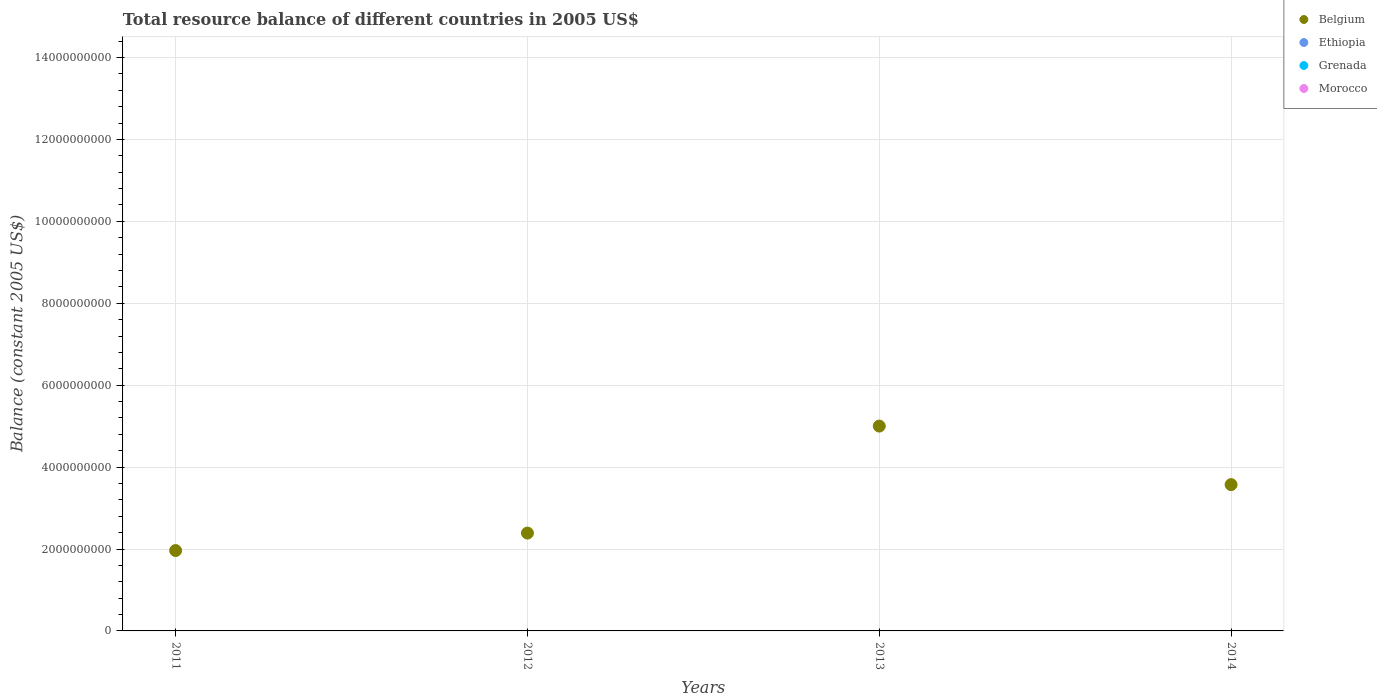Is the number of dotlines equal to the number of legend labels?
Provide a succinct answer. No. What is the total resource balance in Belgium in 2014?
Provide a succinct answer. 3.57e+09. Across all years, what is the maximum total resource balance in Belgium?
Provide a short and direct response. 5.00e+09. What is the total total resource balance in Belgium in the graph?
Offer a very short reply. 1.29e+1. What is the difference between the total resource balance in Belgium in 2011 and that in 2013?
Offer a terse response. -3.04e+09. What is the difference between the total resource balance in Ethiopia in 2011 and the total resource balance in Morocco in 2014?
Your answer should be compact. 0. What is the ratio of the total resource balance in Belgium in 2012 to that in 2014?
Your answer should be compact. 0.67. Is the total resource balance in Belgium in 2011 less than that in 2012?
Ensure brevity in your answer.  Yes. What is the difference between the highest and the second highest total resource balance in Belgium?
Offer a terse response. 1.43e+09. What is the difference between the highest and the lowest total resource balance in Belgium?
Provide a succinct answer. 3.04e+09. Is it the case that in every year, the sum of the total resource balance in Morocco and total resource balance in Ethiopia  is greater than the sum of total resource balance in Belgium and total resource balance in Grenada?
Ensure brevity in your answer.  No. Is it the case that in every year, the sum of the total resource balance in Morocco and total resource balance in Grenada  is greater than the total resource balance in Belgium?
Provide a succinct answer. No. Does the total resource balance in Belgium monotonically increase over the years?
Your response must be concise. No. How many dotlines are there?
Your response must be concise. 1. What is the difference between two consecutive major ticks on the Y-axis?
Provide a short and direct response. 2.00e+09. Where does the legend appear in the graph?
Your answer should be very brief. Top right. How many legend labels are there?
Make the answer very short. 4. What is the title of the graph?
Your answer should be compact. Total resource balance of different countries in 2005 US$. What is the label or title of the Y-axis?
Your answer should be compact. Balance (constant 2005 US$). What is the Balance (constant 2005 US$) in Belgium in 2011?
Your answer should be very brief. 1.96e+09. What is the Balance (constant 2005 US$) in Ethiopia in 2011?
Ensure brevity in your answer.  0. What is the Balance (constant 2005 US$) of Belgium in 2012?
Provide a short and direct response. 2.39e+09. What is the Balance (constant 2005 US$) in Grenada in 2012?
Your answer should be compact. 0. What is the Balance (constant 2005 US$) in Morocco in 2012?
Your response must be concise. 0. What is the Balance (constant 2005 US$) of Belgium in 2013?
Your response must be concise. 5.00e+09. What is the Balance (constant 2005 US$) of Belgium in 2014?
Your response must be concise. 3.57e+09. What is the Balance (constant 2005 US$) in Ethiopia in 2014?
Offer a terse response. 0. What is the Balance (constant 2005 US$) in Grenada in 2014?
Your answer should be very brief. 0. What is the Balance (constant 2005 US$) in Morocco in 2014?
Your answer should be compact. 0. Across all years, what is the maximum Balance (constant 2005 US$) of Belgium?
Offer a very short reply. 5.00e+09. Across all years, what is the minimum Balance (constant 2005 US$) of Belgium?
Provide a succinct answer. 1.96e+09. What is the total Balance (constant 2005 US$) of Belgium in the graph?
Make the answer very short. 1.29e+1. What is the total Balance (constant 2005 US$) of Ethiopia in the graph?
Your answer should be compact. 0. What is the total Balance (constant 2005 US$) of Morocco in the graph?
Your answer should be compact. 0. What is the difference between the Balance (constant 2005 US$) of Belgium in 2011 and that in 2012?
Keep it short and to the point. -4.27e+08. What is the difference between the Balance (constant 2005 US$) in Belgium in 2011 and that in 2013?
Offer a terse response. -3.04e+09. What is the difference between the Balance (constant 2005 US$) in Belgium in 2011 and that in 2014?
Make the answer very short. -1.61e+09. What is the difference between the Balance (constant 2005 US$) in Belgium in 2012 and that in 2013?
Your answer should be very brief. -2.61e+09. What is the difference between the Balance (constant 2005 US$) of Belgium in 2012 and that in 2014?
Provide a succinct answer. -1.18e+09. What is the difference between the Balance (constant 2005 US$) in Belgium in 2013 and that in 2014?
Your answer should be compact. 1.43e+09. What is the average Balance (constant 2005 US$) in Belgium per year?
Offer a terse response. 3.23e+09. What is the average Balance (constant 2005 US$) of Grenada per year?
Ensure brevity in your answer.  0. What is the ratio of the Balance (constant 2005 US$) of Belgium in 2011 to that in 2012?
Keep it short and to the point. 0.82. What is the ratio of the Balance (constant 2005 US$) in Belgium in 2011 to that in 2013?
Offer a very short reply. 0.39. What is the ratio of the Balance (constant 2005 US$) in Belgium in 2011 to that in 2014?
Keep it short and to the point. 0.55. What is the ratio of the Balance (constant 2005 US$) of Belgium in 2012 to that in 2013?
Keep it short and to the point. 0.48. What is the ratio of the Balance (constant 2005 US$) in Belgium in 2012 to that in 2014?
Give a very brief answer. 0.67. What is the ratio of the Balance (constant 2005 US$) of Belgium in 2013 to that in 2014?
Ensure brevity in your answer.  1.4. What is the difference between the highest and the second highest Balance (constant 2005 US$) of Belgium?
Ensure brevity in your answer.  1.43e+09. What is the difference between the highest and the lowest Balance (constant 2005 US$) of Belgium?
Offer a terse response. 3.04e+09. 